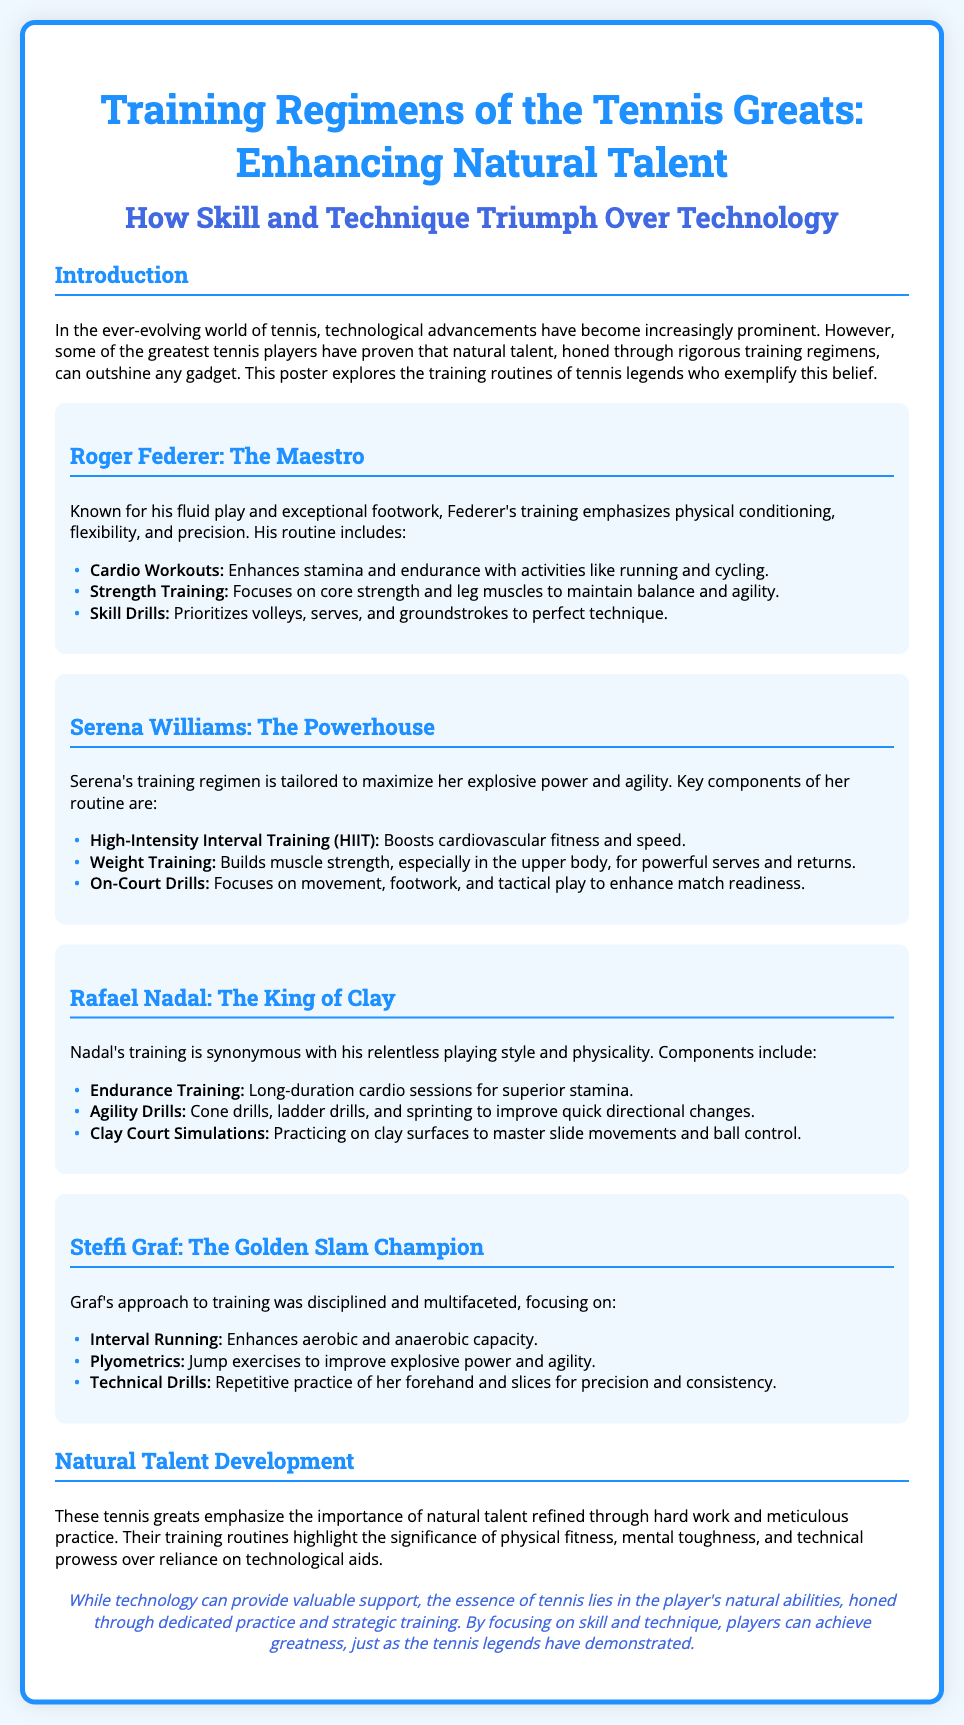what is the title of the poster? The title of the poster is prominently displayed at the top, which is "Training Regimens of the Tennis Greats: Enhancing Natural Talent."
Answer: Training Regimens of the Tennis Greats: Enhancing Natural Talent who is referred to as "The Maestro"? The section specifically mentions Roger Federer and refers to him as "The Maestro."
Answer: Roger Federer what training method is emphasized in Serena Williams' regimen? The poster describes Serena Williams' training regimen, highlighting High-Intensity Interval Training (HIIT) as a key component.
Answer: High-Intensity Interval Training (HIIT) which player emphasizes endurance training? The document lists Rafael Nadal and indicates that he emphasizes endurance training as part of his routine.
Answer: Rafael Nadal how many key components are listed in Steffi Graf's training regimen? The section on Steffi Graf mentions three key components of her training regimen, including interval running, plyometrics, and technical drills.
Answer: Three what does the conclusion suggest about the role of technology in tennis? The conclusion states that while technology can provide support, the essence of tennis remains in the player's natural abilities honed through practice.
Answer: The essence of tennis lies in the player's natural abilities which physical quality does Roger Federer's training focus on? The document indicates that Roger Federer's training focuses on physical conditioning, which includes enhancing flexibility and precision.
Answer: Physical conditioning name one training drill practiced by Rafael Nadal. The section discussing Rafael Nadal lists "Clay Court Simulations" as one of the drills he practices.
Answer: Clay Court Simulations 